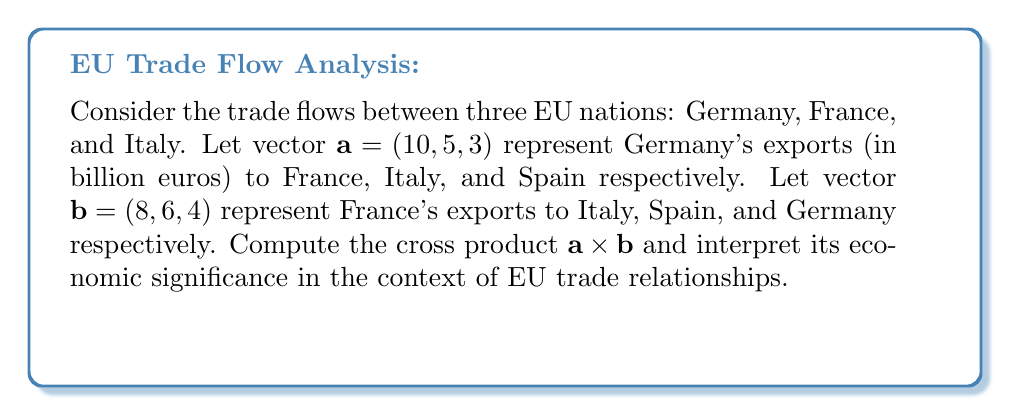Show me your answer to this math problem. To compute the cross product $\mathbf{a} \times \mathbf{b}$, we use the formula:

$$\mathbf{a} \times \mathbf{b} = (a_2b_3 - a_3b_2, a_3b_1 - a_1b_3, a_1b_2 - a_2b_1)$$

Where $\mathbf{a} = (a_1, a_2, a_3)$ and $\mathbf{b} = (b_1, b_2, b_3)$.

Step 1: Identify the components
$\mathbf{a} = (10, 5, 3)$ and $\mathbf{b} = (8, 6, 4)$

Step 2: Calculate each component of the cross product
First component: $a_2b_3 - a_3b_2 = 5(4) - 3(6) = 20 - 18 = 2$
Second component: $a_3b_1 - a_1b_3 = 3(8) - 10(4) = 24 - 40 = -14$
Third component: $a_1b_2 - a_2b_1 = 10(6) - 5(8) = 60 - 40 = 20$

Step 3: Combine the results
$\mathbf{a} \times \mathbf{b} = (2, -14, 20)$

Interpretation: The magnitude of the cross product represents the volume of the parallelogram formed by the two vectors, which in this context could be interpreted as a measure of the overall trade interaction between these countries. The direction of the resulting vector (perpendicular to both $\mathbf{a}$ and $\mathbf{b}$) could indicate potential areas for trade expansion or diversification among these EU nations.
Answer: $\mathbf{a} \times \mathbf{b} = (2, -14, 20)$ 